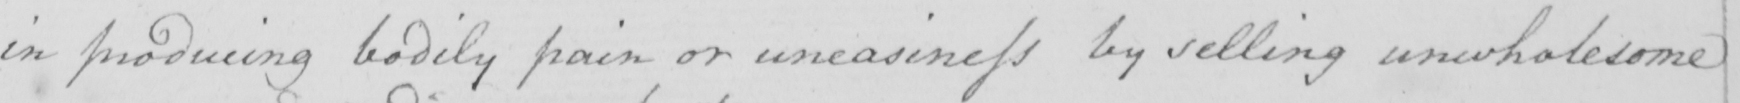What is written in this line of handwriting? in producing bodily pain or uneasiness by selling unwholesome 